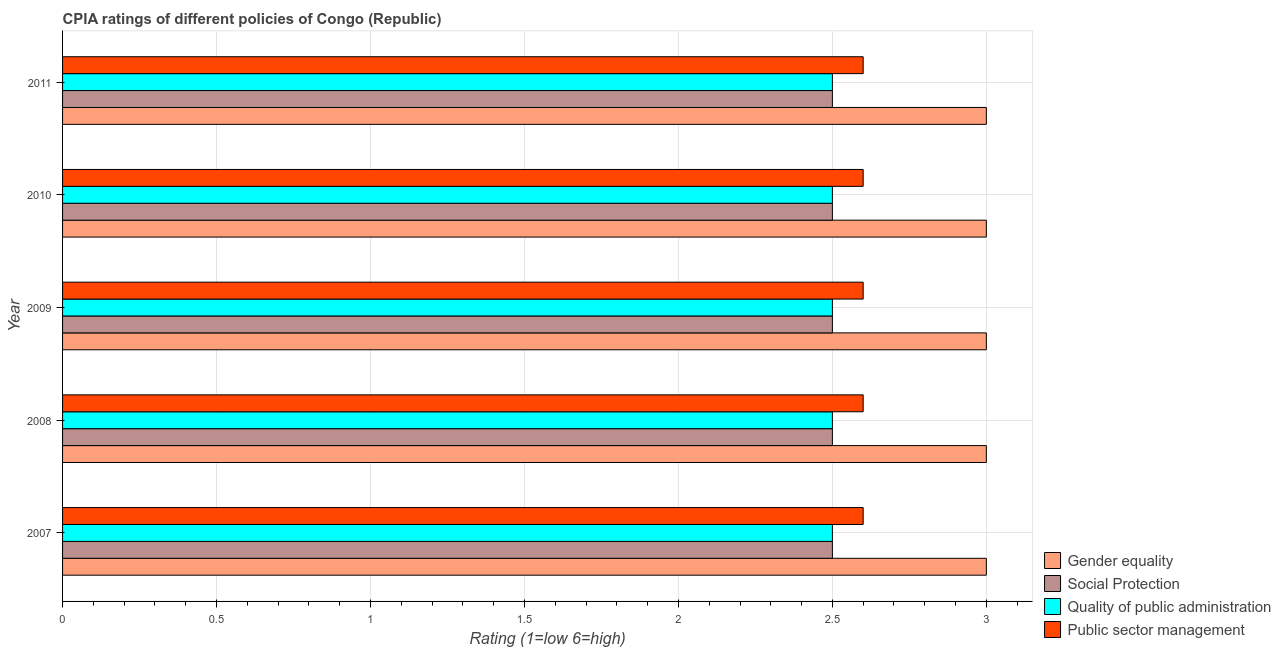How many different coloured bars are there?
Provide a short and direct response. 4. How many groups of bars are there?
Ensure brevity in your answer.  5. Are the number of bars per tick equal to the number of legend labels?
Keep it short and to the point. Yes. How many bars are there on the 4th tick from the top?
Make the answer very short. 4. How many bars are there on the 1st tick from the bottom?
Offer a very short reply. 4. What is the cpia rating of gender equality in 2010?
Make the answer very short. 3. Across all years, what is the maximum cpia rating of public sector management?
Your answer should be compact. 2.6. Across all years, what is the minimum cpia rating of social protection?
Give a very brief answer. 2.5. In which year was the cpia rating of social protection maximum?
Offer a very short reply. 2007. What is the difference between the cpia rating of gender equality in 2007 and the cpia rating of quality of public administration in 2008?
Give a very brief answer. 0.5. What is the average cpia rating of public sector management per year?
Give a very brief answer. 2.6. In the year 2007, what is the difference between the cpia rating of gender equality and cpia rating of public sector management?
Give a very brief answer. 0.4. In how many years, is the cpia rating of social protection greater than 0.9 ?
Ensure brevity in your answer.  5. What is the ratio of the cpia rating of public sector management in 2007 to that in 2011?
Give a very brief answer. 1. Is the cpia rating of gender equality in 2009 less than that in 2011?
Provide a short and direct response. No. Is the difference between the cpia rating of gender equality in 2007 and 2010 greater than the difference between the cpia rating of public sector management in 2007 and 2010?
Keep it short and to the point. No. What is the difference between the highest and the second highest cpia rating of gender equality?
Make the answer very short. 0. In how many years, is the cpia rating of public sector management greater than the average cpia rating of public sector management taken over all years?
Give a very brief answer. 0. Is it the case that in every year, the sum of the cpia rating of public sector management and cpia rating of social protection is greater than the sum of cpia rating of quality of public administration and cpia rating of gender equality?
Offer a terse response. No. What does the 3rd bar from the top in 2010 represents?
Your answer should be compact. Social Protection. What does the 3rd bar from the bottom in 2010 represents?
Ensure brevity in your answer.  Quality of public administration. How many bars are there?
Provide a succinct answer. 20. Does the graph contain any zero values?
Give a very brief answer. No. How many legend labels are there?
Your response must be concise. 4. What is the title of the graph?
Your answer should be very brief. CPIA ratings of different policies of Congo (Republic). Does "Agriculture" appear as one of the legend labels in the graph?
Provide a short and direct response. No. What is the label or title of the X-axis?
Your answer should be compact. Rating (1=low 6=high). What is the label or title of the Y-axis?
Ensure brevity in your answer.  Year. What is the Rating (1=low 6=high) in Gender equality in 2007?
Your response must be concise. 3. What is the Rating (1=low 6=high) of Quality of public administration in 2007?
Your answer should be very brief. 2.5. What is the Rating (1=low 6=high) in Gender equality in 2008?
Provide a short and direct response. 3. What is the Rating (1=low 6=high) of Quality of public administration in 2008?
Provide a short and direct response. 2.5. What is the Rating (1=low 6=high) in Public sector management in 2009?
Ensure brevity in your answer.  2.6. What is the Rating (1=low 6=high) of Gender equality in 2011?
Provide a succinct answer. 3. What is the Rating (1=low 6=high) of Social Protection in 2011?
Your answer should be compact. 2.5. What is the Rating (1=low 6=high) in Public sector management in 2011?
Keep it short and to the point. 2.6. Across all years, what is the maximum Rating (1=low 6=high) in Quality of public administration?
Offer a terse response. 2.5. Across all years, what is the minimum Rating (1=low 6=high) in Gender equality?
Your response must be concise. 3. Across all years, what is the minimum Rating (1=low 6=high) in Public sector management?
Give a very brief answer. 2.6. What is the total Rating (1=low 6=high) of Gender equality in the graph?
Your answer should be compact. 15. What is the total Rating (1=low 6=high) of Quality of public administration in the graph?
Provide a succinct answer. 12.5. What is the difference between the Rating (1=low 6=high) in Public sector management in 2007 and that in 2008?
Offer a very short reply. 0. What is the difference between the Rating (1=low 6=high) of Quality of public administration in 2007 and that in 2009?
Your response must be concise. 0. What is the difference between the Rating (1=low 6=high) of Social Protection in 2007 and that in 2010?
Provide a short and direct response. 0. What is the difference between the Rating (1=low 6=high) in Social Protection in 2007 and that in 2011?
Make the answer very short. 0. What is the difference between the Rating (1=low 6=high) of Quality of public administration in 2007 and that in 2011?
Your answer should be compact. 0. What is the difference between the Rating (1=low 6=high) in Public sector management in 2007 and that in 2011?
Keep it short and to the point. 0. What is the difference between the Rating (1=low 6=high) of Social Protection in 2008 and that in 2009?
Make the answer very short. 0. What is the difference between the Rating (1=low 6=high) in Gender equality in 2008 and that in 2010?
Make the answer very short. 0. What is the difference between the Rating (1=low 6=high) of Quality of public administration in 2008 and that in 2010?
Offer a terse response. 0. What is the difference between the Rating (1=low 6=high) of Gender equality in 2008 and that in 2011?
Ensure brevity in your answer.  0. What is the difference between the Rating (1=low 6=high) of Social Protection in 2008 and that in 2011?
Offer a terse response. 0. What is the difference between the Rating (1=low 6=high) in Public sector management in 2008 and that in 2011?
Offer a terse response. 0. What is the difference between the Rating (1=low 6=high) of Gender equality in 2010 and that in 2011?
Provide a short and direct response. 0. What is the difference between the Rating (1=low 6=high) of Social Protection in 2010 and that in 2011?
Provide a short and direct response. 0. What is the difference between the Rating (1=low 6=high) in Quality of public administration in 2010 and that in 2011?
Offer a terse response. 0. What is the difference between the Rating (1=low 6=high) of Gender equality in 2007 and the Rating (1=low 6=high) of Social Protection in 2008?
Offer a terse response. 0.5. What is the difference between the Rating (1=low 6=high) in Gender equality in 2007 and the Rating (1=low 6=high) in Public sector management in 2008?
Make the answer very short. 0.4. What is the difference between the Rating (1=low 6=high) of Gender equality in 2007 and the Rating (1=low 6=high) of Social Protection in 2009?
Your response must be concise. 0.5. What is the difference between the Rating (1=low 6=high) of Quality of public administration in 2007 and the Rating (1=low 6=high) of Public sector management in 2009?
Provide a succinct answer. -0.1. What is the difference between the Rating (1=low 6=high) in Social Protection in 2007 and the Rating (1=low 6=high) in Quality of public administration in 2010?
Ensure brevity in your answer.  0. What is the difference between the Rating (1=low 6=high) of Social Protection in 2007 and the Rating (1=low 6=high) of Public sector management in 2010?
Give a very brief answer. -0.1. What is the difference between the Rating (1=low 6=high) of Social Protection in 2007 and the Rating (1=low 6=high) of Quality of public administration in 2011?
Keep it short and to the point. 0. What is the difference between the Rating (1=low 6=high) in Quality of public administration in 2007 and the Rating (1=low 6=high) in Public sector management in 2011?
Make the answer very short. -0.1. What is the difference between the Rating (1=low 6=high) of Gender equality in 2008 and the Rating (1=low 6=high) of Quality of public administration in 2009?
Provide a short and direct response. 0.5. What is the difference between the Rating (1=low 6=high) in Gender equality in 2008 and the Rating (1=low 6=high) in Public sector management in 2009?
Make the answer very short. 0.4. What is the difference between the Rating (1=low 6=high) of Social Protection in 2008 and the Rating (1=low 6=high) of Public sector management in 2009?
Your response must be concise. -0.1. What is the difference between the Rating (1=low 6=high) of Quality of public administration in 2008 and the Rating (1=low 6=high) of Public sector management in 2009?
Provide a succinct answer. -0.1. What is the difference between the Rating (1=low 6=high) of Gender equality in 2008 and the Rating (1=low 6=high) of Quality of public administration in 2010?
Make the answer very short. 0.5. What is the difference between the Rating (1=low 6=high) in Gender equality in 2008 and the Rating (1=low 6=high) in Public sector management in 2010?
Your answer should be compact. 0.4. What is the difference between the Rating (1=low 6=high) of Social Protection in 2008 and the Rating (1=low 6=high) of Public sector management in 2010?
Your answer should be compact. -0.1. What is the difference between the Rating (1=low 6=high) in Gender equality in 2008 and the Rating (1=low 6=high) in Public sector management in 2011?
Your answer should be compact. 0.4. What is the difference between the Rating (1=low 6=high) of Social Protection in 2008 and the Rating (1=low 6=high) of Quality of public administration in 2011?
Offer a very short reply. 0. What is the difference between the Rating (1=low 6=high) of Social Protection in 2008 and the Rating (1=low 6=high) of Public sector management in 2011?
Give a very brief answer. -0.1. What is the difference between the Rating (1=low 6=high) in Gender equality in 2009 and the Rating (1=low 6=high) in Social Protection in 2010?
Offer a very short reply. 0.5. What is the difference between the Rating (1=low 6=high) of Quality of public administration in 2009 and the Rating (1=low 6=high) of Public sector management in 2010?
Provide a short and direct response. -0.1. What is the difference between the Rating (1=low 6=high) of Gender equality in 2009 and the Rating (1=low 6=high) of Social Protection in 2011?
Offer a terse response. 0.5. What is the difference between the Rating (1=low 6=high) of Gender equality in 2009 and the Rating (1=low 6=high) of Quality of public administration in 2011?
Offer a terse response. 0.5. What is the difference between the Rating (1=low 6=high) in Social Protection in 2009 and the Rating (1=low 6=high) in Quality of public administration in 2011?
Ensure brevity in your answer.  0. What is the difference between the Rating (1=low 6=high) of Gender equality in 2010 and the Rating (1=low 6=high) of Social Protection in 2011?
Offer a very short reply. 0.5. What is the difference between the Rating (1=low 6=high) in Social Protection in 2010 and the Rating (1=low 6=high) in Quality of public administration in 2011?
Give a very brief answer. 0. What is the difference between the Rating (1=low 6=high) of Social Protection in 2010 and the Rating (1=low 6=high) of Public sector management in 2011?
Provide a short and direct response. -0.1. What is the average Rating (1=low 6=high) of Gender equality per year?
Your response must be concise. 3. What is the average Rating (1=low 6=high) of Quality of public administration per year?
Keep it short and to the point. 2.5. What is the average Rating (1=low 6=high) in Public sector management per year?
Your answer should be very brief. 2.6. In the year 2007, what is the difference between the Rating (1=low 6=high) of Gender equality and Rating (1=low 6=high) of Quality of public administration?
Give a very brief answer. 0.5. In the year 2007, what is the difference between the Rating (1=low 6=high) of Social Protection and Rating (1=low 6=high) of Quality of public administration?
Provide a short and direct response. 0. In the year 2007, what is the difference between the Rating (1=low 6=high) in Social Protection and Rating (1=low 6=high) in Public sector management?
Give a very brief answer. -0.1. In the year 2007, what is the difference between the Rating (1=low 6=high) of Quality of public administration and Rating (1=low 6=high) of Public sector management?
Offer a very short reply. -0.1. In the year 2008, what is the difference between the Rating (1=low 6=high) of Gender equality and Rating (1=low 6=high) of Social Protection?
Your response must be concise. 0.5. In the year 2008, what is the difference between the Rating (1=low 6=high) of Gender equality and Rating (1=low 6=high) of Quality of public administration?
Your answer should be very brief. 0.5. In the year 2008, what is the difference between the Rating (1=low 6=high) of Social Protection and Rating (1=low 6=high) of Public sector management?
Offer a very short reply. -0.1. In the year 2009, what is the difference between the Rating (1=low 6=high) in Gender equality and Rating (1=low 6=high) in Social Protection?
Your answer should be very brief. 0.5. In the year 2009, what is the difference between the Rating (1=low 6=high) in Gender equality and Rating (1=low 6=high) in Quality of public administration?
Your answer should be very brief. 0.5. In the year 2009, what is the difference between the Rating (1=low 6=high) of Social Protection and Rating (1=low 6=high) of Public sector management?
Keep it short and to the point. -0.1. In the year 2009, what is the difference between the Rating (1=low 6=high) of Quality of public administration and Rating (1=low 6=high) of Public sector management?
Provide a succinct answer. -0.1. In the year 2010, what is the difference between the Rating (1=low 6=high) in Gender equality and Rating (1=low 6=high) in Quality of public administration?
Your answer should be very brief. 0.5. In the year 2010, what is the difference between the Rating (1=low 6=high) in Social Protection and Rating (1=low 6=high) in Quality of public administration?
Provide a short and direct response. 0. In the year 2011, what is the difference between the Rating (1=low 6=high) in Gender equality and Rating (1=low 6=high) in Public sector management?
Provide a short and direct response. 0.4. In the year 2011, what is the difference between the Rating (1=low 6=high) of Social Protection and Rating (1=low 6=high) of Quality of public administration?
Your response must be concise. 0. In the year 2011, what is the difference between the Rating (1=low 6=high) of Social Protection and Rating (1=low 6=high) of Public sector management?
Make the answer very short. -0.1. In the year 2011, what is the difference between the Rating (1=low 6=high) of Quality of public administration and Rating (1=low 6=high) of Public sector management?
Offer a terse response. -0.1. What is the ratio of the Rating (1=low 6=high) of Quality of public administration in 2007 to that in 2008?
Provide a succinct answer. 1. What is the ratio of the Rating (1=low 6=high) in Public sector management in 2007 to that in 2008?
Your answer should be very brief. 1. What is the ratio of the Rating (1=low 6=high) in Quality of public administration in 2007 to that in 2009?
Make the answer very short. 1. What is the ratio of the Rating (1=low 6=high) of Public sector management in 2007 to that in 2009?
Provide a short and direct response. 1. What is the ratio of the Rating (1=low 6=high) in Gender equality in 2007 to that in 2010?
Give a very brief answer. 1. What is the ratio of the Rating (1=low 6=high) in Quality of public administration in 2007 to that in 2010?
Keep it short and to the point. 1. What is the ratio of the Rating (1=low 6=high) in Public sector management in 2007 to that in 2010?
Offer a very short reply. 1. What is the ratio of the Rating (1=low 6=high) in Social Protection in 2007 to that in 2011?
Offer a terse response. 1. What is the ratio of the Rating (1=low 6=high) in Public sector management in 2007 to that in 2011?
Offer a terse response. 1. What is the ratio of the Rating (1=low 6=high) of Gender equality in 2008 to that in 2009?
Your answer should be compact. 1. What is the ratio of the Rating (1=low 6=high) of Social Protection in 2008 to that in 2009?
Provide a short and direct response. 1. What is the ratio of the Rating (1=low 6=high) of Gender equality in 2008 to that in 2011?
Ensure brevity in your answer.  1. What is the ratio of the Rating (1=low 6=high) in Social Protection in 2008 to that in 2011?
Offer a very short reply. 1. What is the ratio of the Rating (1=low 6=high) of Quality of public administration in 2008 to that in 2011?
Ensure brevity in your answer.  1. What is the ratio of the Rating (1=low 6=high) in Quality of public administration in 2009 to that in 2010?
Keep it short and to the point. 1. What is the ratio of the Rating (1=low 6=high) of Public sector management in 2009 to that in 2011?
Keep it short and to the point. 1. What is the ratio of the Rating (1=low 6=high) in Gender equality in 2010 to that in 2011?
Your response must be concise. 1. What is the ratio of the Rating (1=low 6=high) in Social Protection in 2010 to that in 2011?
Provide a succinct answer. 1. What is the ratio of the Rating (1=low 6=high) in Quality of public administration in 2010 to that in 2011?
Your response must be concise. 1. What is the ratio of the Rating (1=low 6=high) of Public sector management in 2010 to that in 2011?
Provide a short and direct response. 1. What is the difference between the highest and the second highest Rating (1=low 6=high) of Quality of public administration?
Keep it short and to the point. 0. What is the difference between the highest and the lowest Rating (1=low 6=high) of Gender equality?
Keep it short and to the point. 0. What is the difference between the highest and the lowest Rating (1=low 6=high) of Public sector management?
Offer a very short reply. 0. 